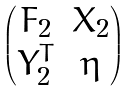<formula> <loc_0><loc_0><loc_500><loc_500>\begin{pmatrix} F _ { 2 } & X _ { 2 } \\ Y _ { 2 } ^ { T } & \eta \end{pmatrix}</formula> 